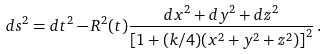<formula> <loc_0><loc_0><loc_500><loc_500>d s ^ { 2 } = d t ^ { 2 } - R ^ { 2 } ( t ) \frac { d x ^ { 2 } + d y ^ { 2 } + d z ^ { 2 } } { \left [ 1 + ( k / 4 ) ( x ^ { 2 } + y ^ { 2 } + z ^ { 2 } ) \right ] ^ { 2 } } \, .</formula> 